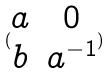<formula> <loc_0><loc_0><loc_500><loc_500>( \begin{matrix} a & 0 \\ b & a ^ { - 1 } \end{matrix} )</formula> 